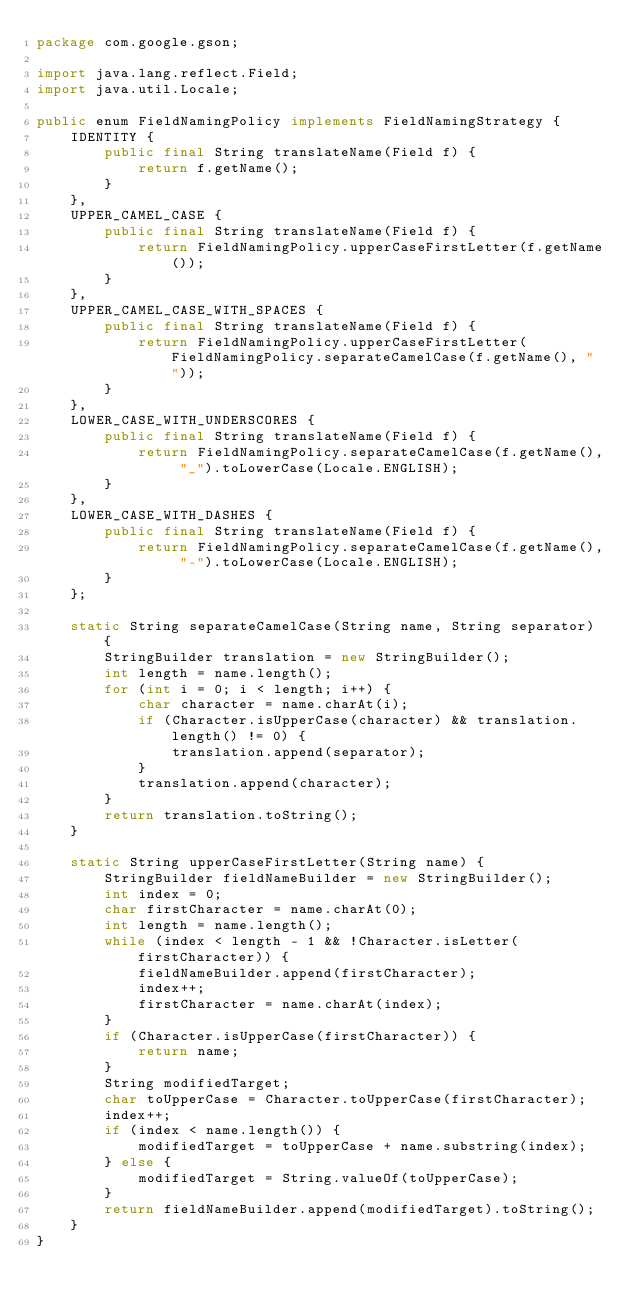Convert code to text. <code><loc_0><loc_0><loc_500><loc_500><_Java_>package com.google.gson;

import java.lang.reflect.Field;
import java.util.Locale;

public enum FieldNamingPolicy implements FieldNamingStrategy {
    IDENTITY {
        public final String translateName(Field f) {
            return f.getName();
        }
    },
    UPPER_CAMEL_CASE {
        public final String translateName(Field f) {
            return FieldNamingPolicy.upperCaseFirstLetter(f.getName());
        }
    },
    UPPER_CAMEL_CASE_WITH_SPACES {
        public final String translateName(Field f) {
            return FieldNamingPolicy.upperCaseFirstLetter(FieldNamingPolicy.separateCamelCase(f.getName(), " "));
        }
    },
    LOWER_CASE_WITH_UNDERSCORES {
        public final String translateName(Field f) {
            return FieldNamingPolicy.separateCamelCase(f.getName(), "_").toLowerCase(Locale.ENGLISH);
        }
    },
    LOWER_CASE_WITH_DASHES {
        public final String translateName(Field f) {
            return FieldNamingPolicy.separateCamelCase(f.getName(), "-").toLowerCase(Locale.ENGLISH);
        }
    };

    static String separateCamelCase(String name, String separator) {
        StringBuilder translation = new StringBuilder();
        int length = name.length();
        for (int i = 0; i < length; i++) {
            char character = name.charAt(i);
            if (Character.isUpperCase(character) && translation.length() != 0) {
                translation.append(separator);
            }
            translation.append(character);
        }
        return translation.toString();
    }

    static String upperCaseFirstLetter(String name) {
        StringBuilder fieldNameBuilder = new StringBuilder();
        int index = 0;
        char firstCharacter = name.charAt(0);
        int length = name.length();
        while (index < length - 1 && !Character.isLetter(firstCharacter)) {
            fieldNameBuilder.append(firstCharacter);
            index++;
            firstCharacter = name.charAt(index);
        }
        if (Character.isUpperCase(firstCharacter)) {
            return name;
        }
        String modifiedTarget;
        char toUpperCase = Character.toUpperCase(firstCharacter);
        index++;
        if (index < name.length()) {
            modifiedTarget = toUpperCase + name.substring(index);
        } else {
            modifiedTarget = String.valueOf(toUpperCase);
        }
        return fieldNameBuilder.append(modifiedTarget).toString();
    }
}
</code> 